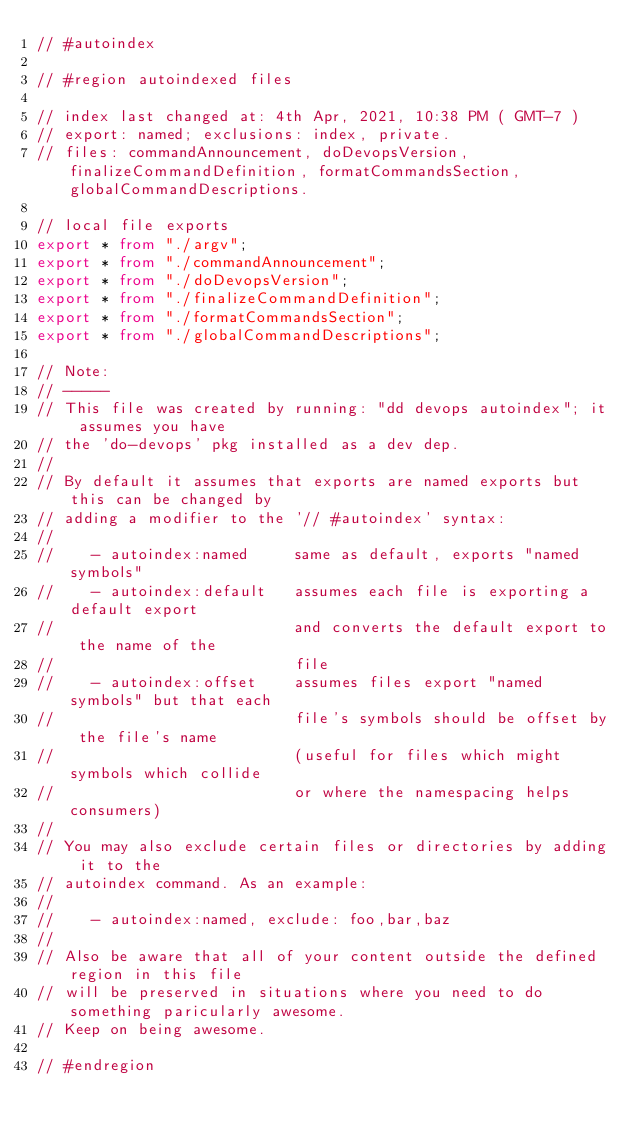Convert code to text. <code><loc_0><loc_0><loc_500><loc_500><_TypeScript_>// #autoindex

// #region autoindexed files

// index last changed at: 4th Apr, 2021, 10:38 PM ( GMT-7 )
// export: named; exclusions: index, private.
// files: commandAnnouncement, doDevopsVersion, finalizeCommandDefinition, formatCommandsSection, globalCommandDescriptions.

// local file exports
export * from "./argv";
export * from "./commandAnnouncement";
export * from "./doDevopsVersion";
export * from "./finalizeCommandDefinition";
export * from "./formatCommandsSection";
export * from "./globalCommandDescriptions";

// Note:
// -----
// This file was created by running: "dd devops autoindex"; it assumes you have
// the 'do-devops' pkg installed as a dev dep.
//
// By default it assumes that exports are named exports but this can be changed by
// adding a modifier to the '// #autoindex' syntax:
//
//    - autoindex:named     same as default, exports "named symbols"
//    - autoindex:default   assumes each file is exporting a default export
//                          and converts the default export to the name of the
//                          file
//    - autoindex:offset    assumes files export "named symbols" but that each
//                          file's symbols should be offset by the file's name
//                          (useful for files which might symbols which collide
//                          or where the namespacing helps consumers)
//
// You may also exclude certain files or directories by adding it to the
// autoindex command. As an example:
//
//    - autoindex:named, exclude: foo,bar,baz
//
// Also be aware that all of your content outside the defined region in this file
// will be preserved in situations where you need to do something paricularly awesome.
// Keep on being awesome.

// #endregion
</code> 